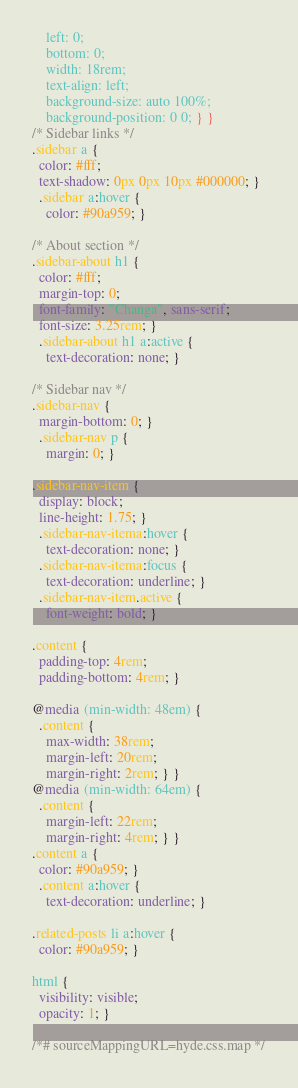Convert code to text. <code><loc_0><loc_0><loc_500><loc_500><_CSS_>    left: 0;
    bottom: 0;
    width: 18rem;
    text-align: left;
    background-size: auto 100%;
    background-position: 0 0; } }
/* Sidebar links */
.sidebar a {
  color: #fff;
  text-shadow: 0px 0px 10px #000000; }
  .sidebar a:hover {
    color: #90a959; }

/* About section */
.sidebar-about h1 {
  color: #fff;
  margin-top: 0;
  font-family: "Changa", sans-serif;
  font-size: 3.25rem; }
  .sidebar-about h1 a:active {
    text-decoration: none; }

/* Sidebar nav */
.sidebar-nav {
  margin-bottom: 0; }
  .sidebar-nav p {
    margin: 0; }

.sidebar-nav-item {
  display: block;
  line-height: 1.75; }
  .sidebar-nav-itema:hover {
    text-decoration: none; }
  .sidebar-nav-itema:focus {
    text-decoration: underline; }
  .sidebar-nav-item.active {
    font-weight: bold; }

.content {
  padding-top: 4rem;
  padding-bottom: 4rem; }

@media (min-width: 48em) {
  .content {
    max-width: 38rem;
    margin-left: 20rem;
    margin-right: 2rem; } }
@media (min-width: 64em) {
  .content {
    margin-left: 22rem;
    margin-right: 4rem; } }
.content a {
  color: #90a959; }
  .content a:hover {
    text-decoration: underline; }

.related-posts li a:hover {
  color: #90a959; }

html {
  visibility: visible;
  opacity: 1; }

/*# sourceMappingURL=hyde.css.map */
</code> 